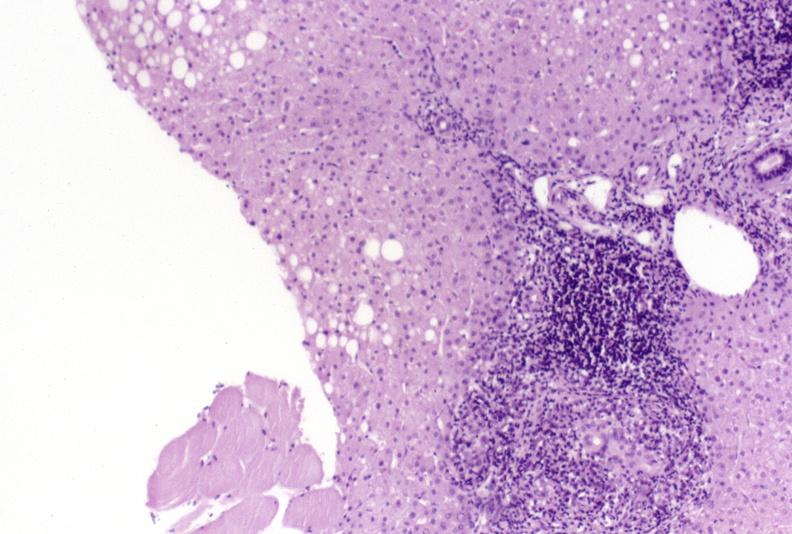does polysplenia show primary biliary cirrhosis?
Answer the question using a single word or phrase. No 